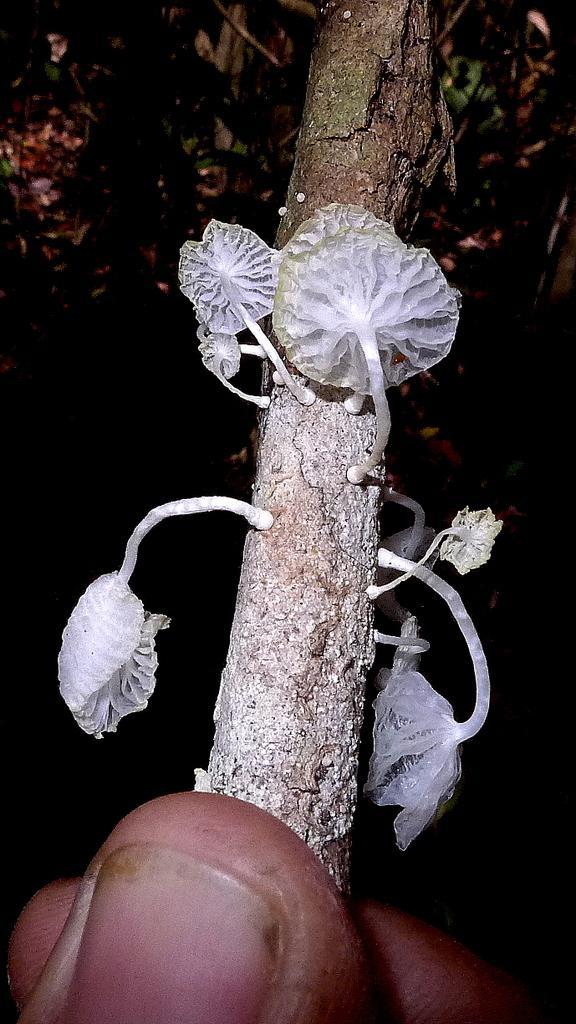Could you give a brief overview of what you see in this image? In the picture there is a person holding a stem with the hand, on the stem we can see some white color objects. 